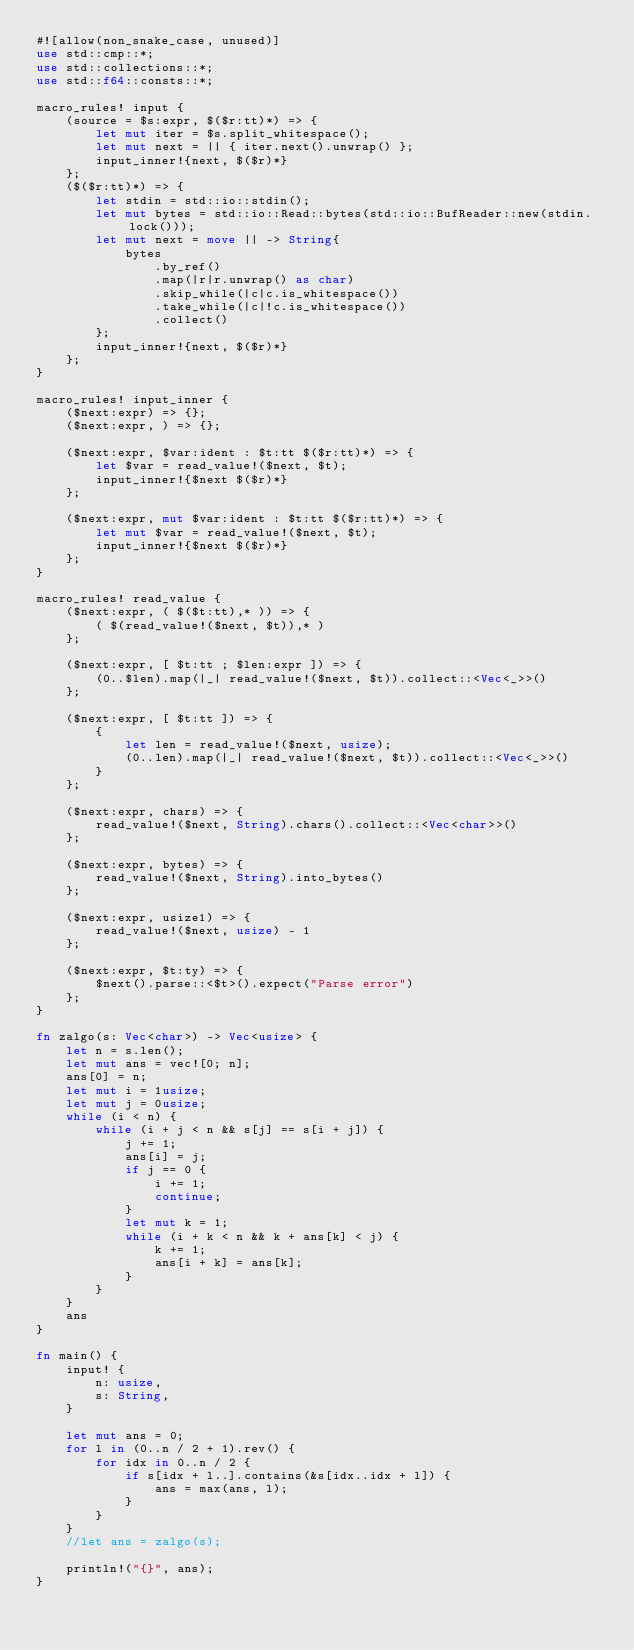Convert code to text. <code><loc_0><loc_0><loc_500><loc_500><_Rust_>#![allow(non_snake_case, unused)]
use std::cmp::*;
use std::collections::*;
use std::f64::consts::*;

macro_rules! input {
    (source = $s:expr, $($r:tt)*) => {
        let mut iter = $s.split_whitespace();
        let mut next = || { iter.next().unwrap() };
        input_inner!{next, $($r)*}
    };
    ($($r:tt)*) => {
        let stdin = std::io::stdin();
        let mut bytes = std::io::Read::bytes(std::io::BufReader::new(stdin.lock()));
        let mut next = move || -> String{
            bytes
                .by_ref()
                .map(|r|r.unwrap() as char)
                .skip_while(|c|c.is_whitespace())
                .take_while(|c|!c.is_whitespace())
                .collect()
        };
        input_inner!{next, $($r)*}
    };
}

macro_rules! input_inner {
    ($next:expr) => {};
    ($next:expr, ) => {};

    ($next:expr, $var:ident : $t:tt $($r:tt)*) => {
        let $var = read_value!($next, $t);
        input_inner!{$next $($r)*}
    };

    ($next:expr, mut $var:ident : $t:tt $($r:tt)*) => {
        let mut $var = read_value!($next, $t);
        input_inner!{$next $($r)*}
    };
}

macro_rules! read_value {
    ($next:expr, ( $($t:tt),* )) => {
        ( $(read_value!($next, $t)),* )
    };

    ($next:expr, [ $t:tt ; $len:expr ]) => {
        (0..$len).map(|_| read_value!($next, $t)).collect::<Vec<_>>()
    };

    ($next:expr, [ $t:tt ]) => {
        {
            let len = read_value!($next, usize);
            (0..len).map(|_| read_value!($next, $t)).collect::<Vec<_>>()
        }
    };

    ($next:expr, chars) => {
        read_value!($next, String).chars().collect::<Vec<char>>()
    };

    ($next:expr, bytes) => {
        read_value!($next, String).into_bytes()
    };

    ($next:expr, usize1) => {
        read_value!($next, usize) - 1
    };

    ($next:expr, $t:ty) => {
        $next().parse::<$t>().expect("Parse error")
    };
}

fn zalgo(s: Vec<char>) -> Vec<usize> {
    let n = s.len();
    let mut ans = vec![0; n];
    ans[0] = n;
    let mut i = 1usize;
    let mut j = 0usize;
    while (i < n) {
        while (i + j < n && s[j] == s[i + j]) {
            j += 1;
            ans[i] = j;
            if j == 0 {
                i += 1;
                continue;
            }
            let mut k = 1;
            while (i + k < n && k + ans[k] < j) {
                k += 1;
                ans[i + k] = ans[k];
            }
        }
    }
    ans
}

fn main() {
    input! {
        n: usize,
        s: String,
    }

    let mut ans = 0;
    for l in (0..n / 2 + 1).rev() {
        for idx in 0..n / 2 {
            if s[idx + l..].contains(&s[idx..idx + l]) {
                ans = max(ans, l);
            }
        }
    }
    //let ans = zalgo(s);

    println!("{}", ans);
}
</code> 